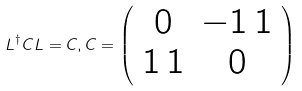<formula> <loc_0><loc_0><loc_500><loc_500>L ^ { \dagger } C L = C , C = \left ( \begin{array} { c c } 0 & - 1 \, 1 \\ 1 \, 1 & 0 \\ \end{array} \right )</formula> 